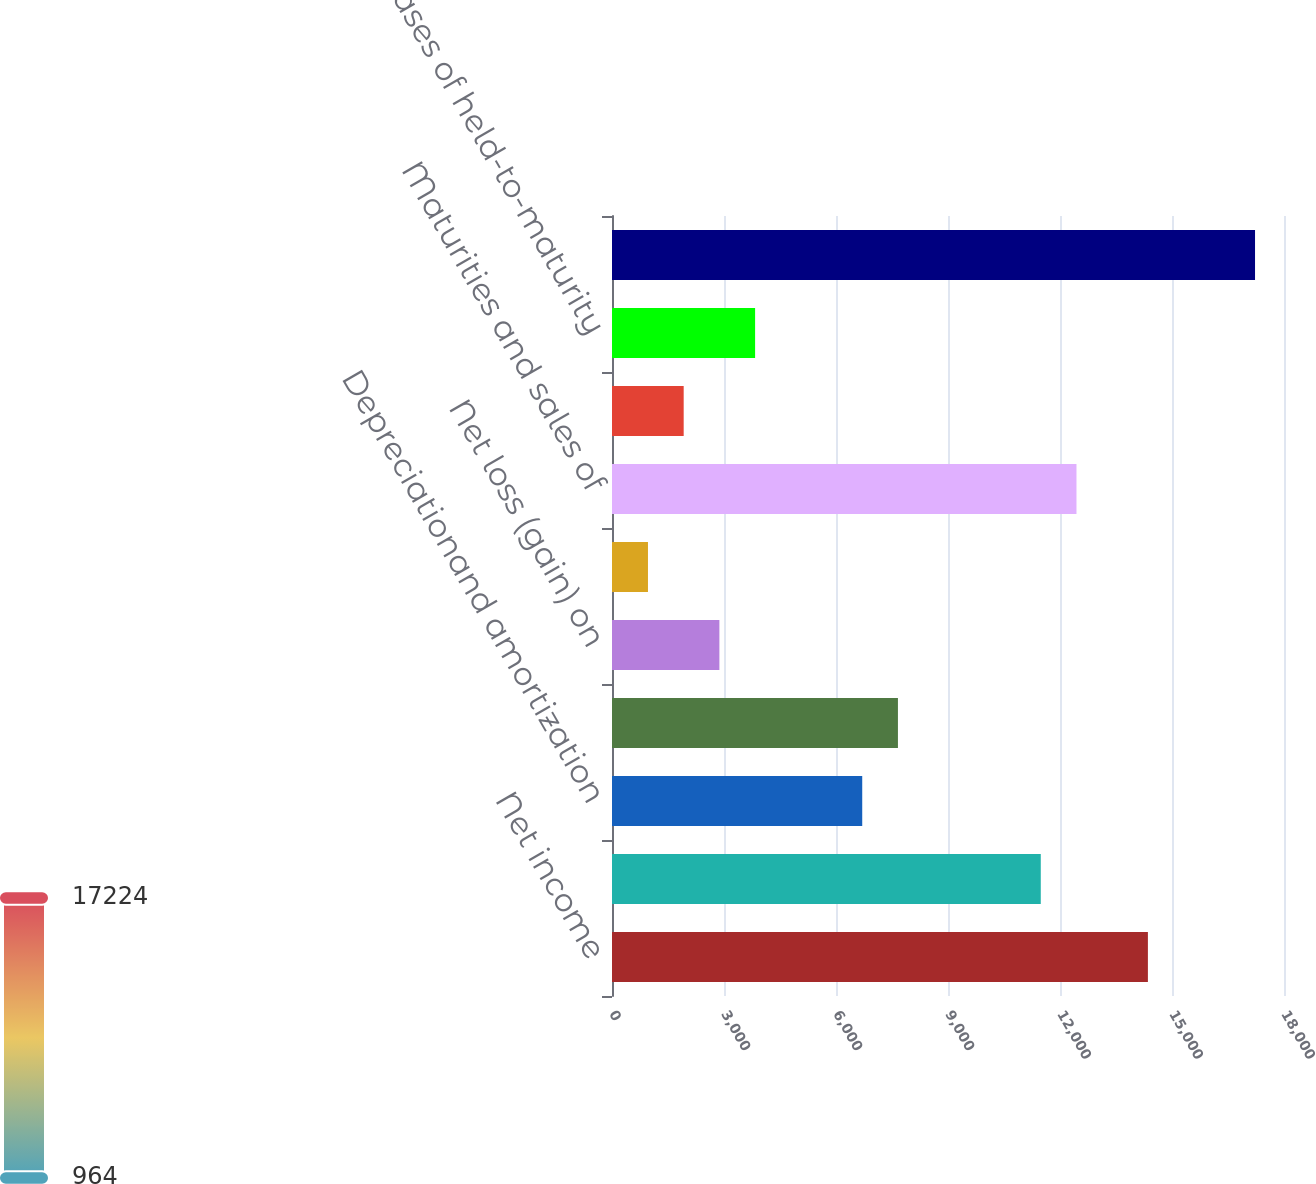Convert chart to OTSL. <chart><loc_0><loc_0><loc_500><loc_500><bar_chart><fcel>Net income<fcel>Provisionfor loan losses<fcel>Depreciationand amortization<fcel>Amortizationofdeferred<fcel>Net loss (gain) on<fcel>Other net<fcel>Maturities and sales of<fcel>Maturities of held-to-maturity<fcel>Purchases of held-to-maturity<fcel>Net principal disbursed on<nl><fcel>14354.5<fcel>11485<fcel>6702.5<fcel>7659<fcel>2876.5<fcel>963.5<fcel>12441.5<fcel>1920<fcel>3833<fcel>17224<nl></chart> 